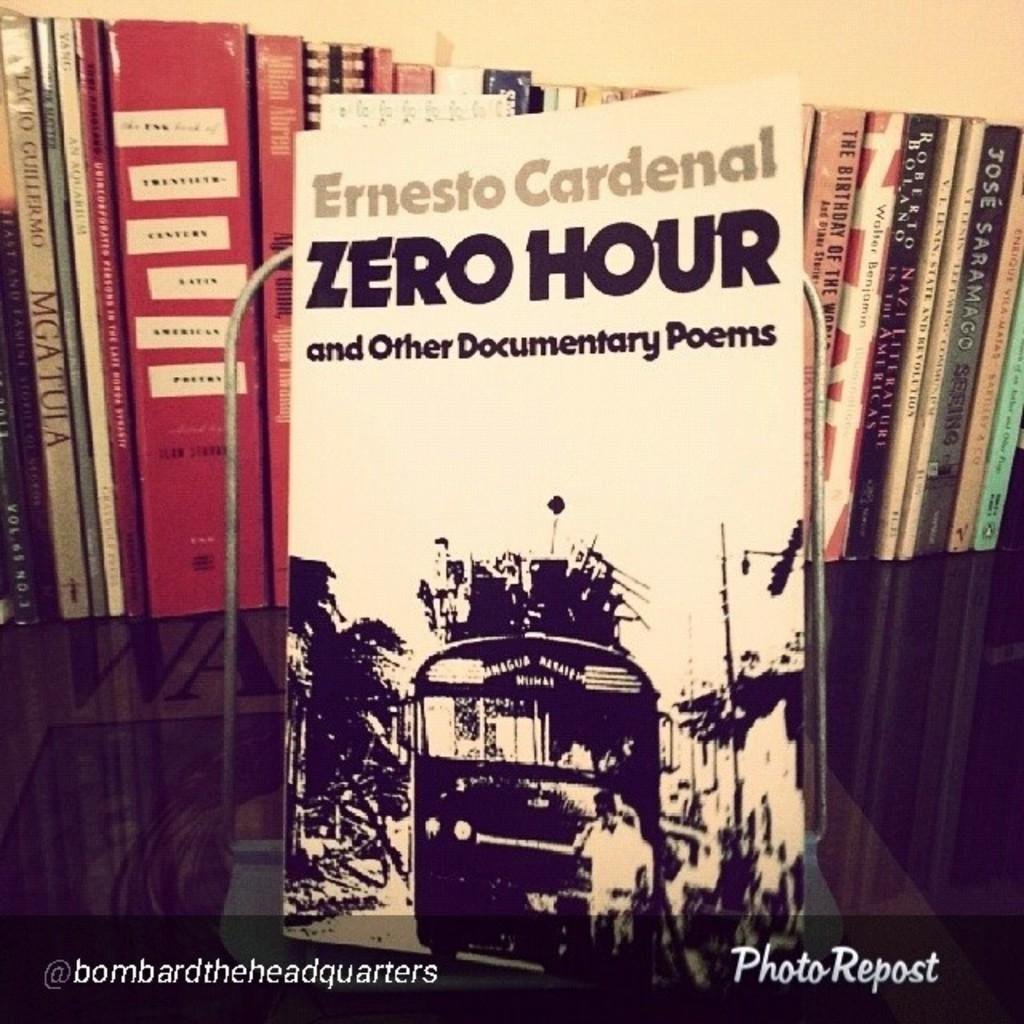<image>
Create a compact narrative representing the image presented. The Zero Hour by Ernesto Cardenal is on display 